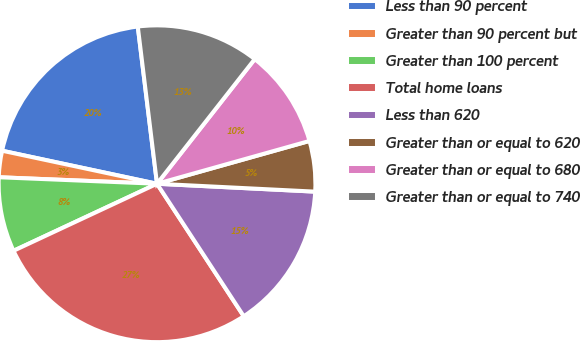Convert chart to OTSL. <chart><loc_0><loc_0><loc_500><loc_500><pie_chart><fcel>Less than 90 percent<fcel>Greater than 90 percent but<fcel>Greater than 100 percent<fcel>Total home loans<fcel>Less than 620<fcel>Greater than or equal to 620<fcel>Greater than or equal to 680<fcel>Greater than or equal to 740<nl><fcel>19.72%<fcel>2.69%<fcel>7.61%<fcel>27.27%<fcel>14.98%<fcel>5.15%<fcel>10.06%<fcel>12.52%<nl></chart> 